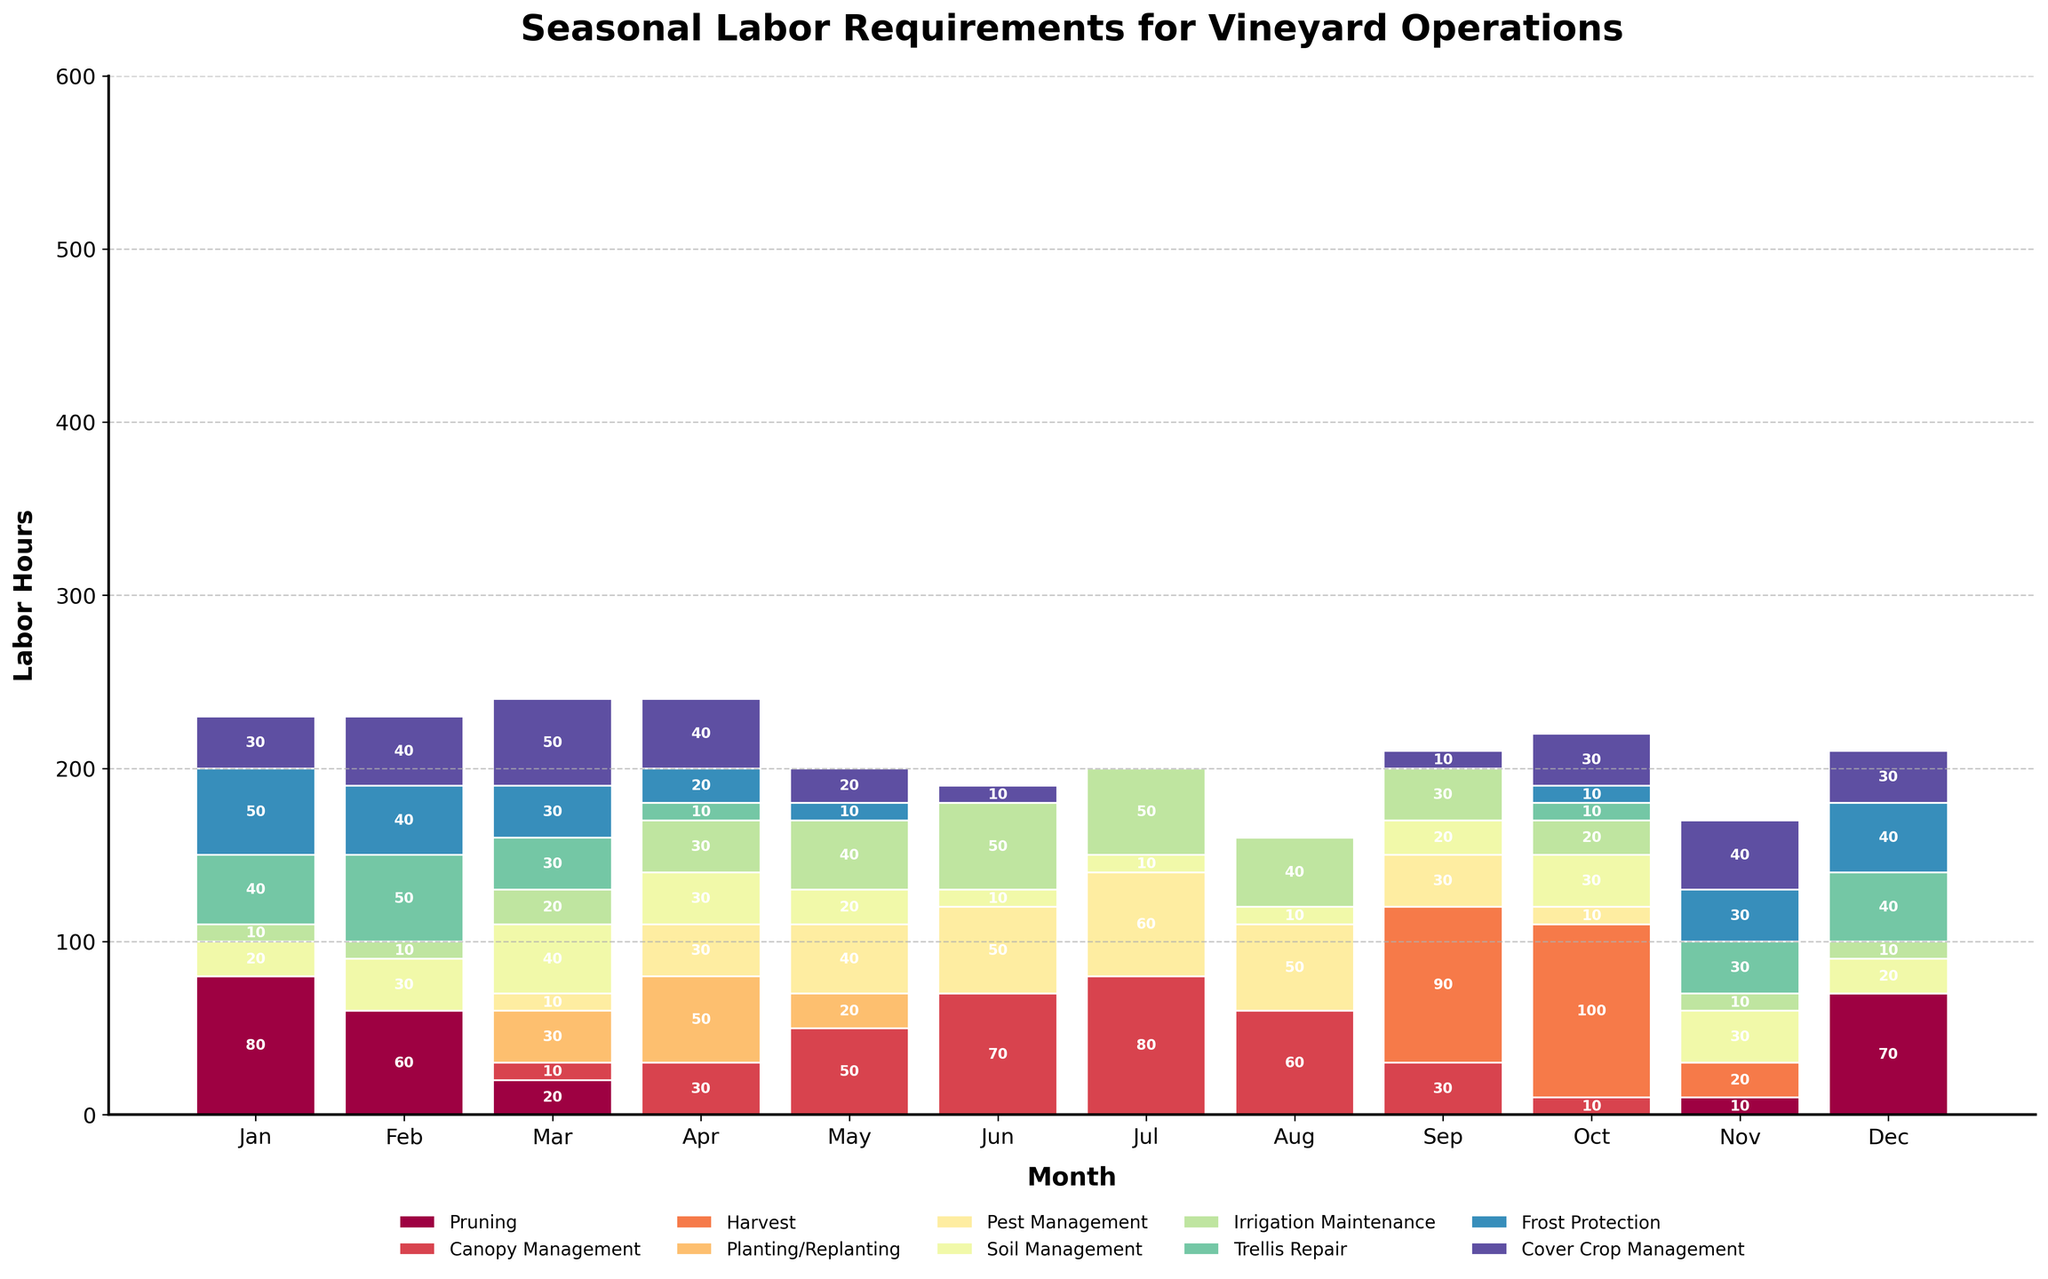What is the operation with the highest labor requirement in January? By observing the height of the bars for January, we see that 'Pruning' has the highest labor requirement with a value of 80 hours.
Answer: Pruning During which month does 'Harvest' require the most labor? Looking at the segment of the bar representing 'Harvest,' we see that it peaks in October with a value of 100 hours.
Answer: October Which operation has a constant requirement throughout the year, if any? No operation has a completely constant requirement, but 'Soil Management' has a relatively consistent labor requirement with smaller variation compared to other operations.
Answer: Soil Management Is the labor requirement for 'Trellis Repair' in January higher or lower than 'Canopy Management' in July? We compare the height of the bars: 'Trellis Repair' in January is 40 hours while 'Canopy Management' in July is 80 hours. The latter is higher.
Answer: Lower What is the total labor requirement for 'Pest Management' in June and July combined? The labor requirements for 'Pest Management' in June and July are 50 and 60 hours, respectively. Summing them gives 50 + 60 = 110 hours.
Answer: 110 hours Which month has the highest cumulative labor requirement across all operations? Observing the cumulative height of all bars for each month, September appears to have the highest total labor requirement.
Answer: September What is the difference in labor requirement for 'Pruning' between November and December? The labor requirement for 'Pruning' in November is 10 hours and in December is 70 hours. The difference is 70 - 10 = 60 hours.
Answer: 60 hours In which month does 'Canopy Management' require the most labor, and what is the amount? By checking the highest bar segment for 'Canopy Management', it peaks in July with a value of 80 hours.
Answer: July, 80 hours Does 'Irrigation Maintenance' have a higher labor requirement in June or October? By comparing the bars, 'Irrigation Maintenance' requires 50 hours in June and 20 hours in October.
Answer: June If we sum up the labor requirements for 'Cover Crop Management' from February to April, what would be the total? The labor requirements for 'Cover Crop Management' are 40 in February, 50 in March, and 40 in April. Summing them gives 40 + 50 + 40 = 130 hours.
Answer: 130 hours 